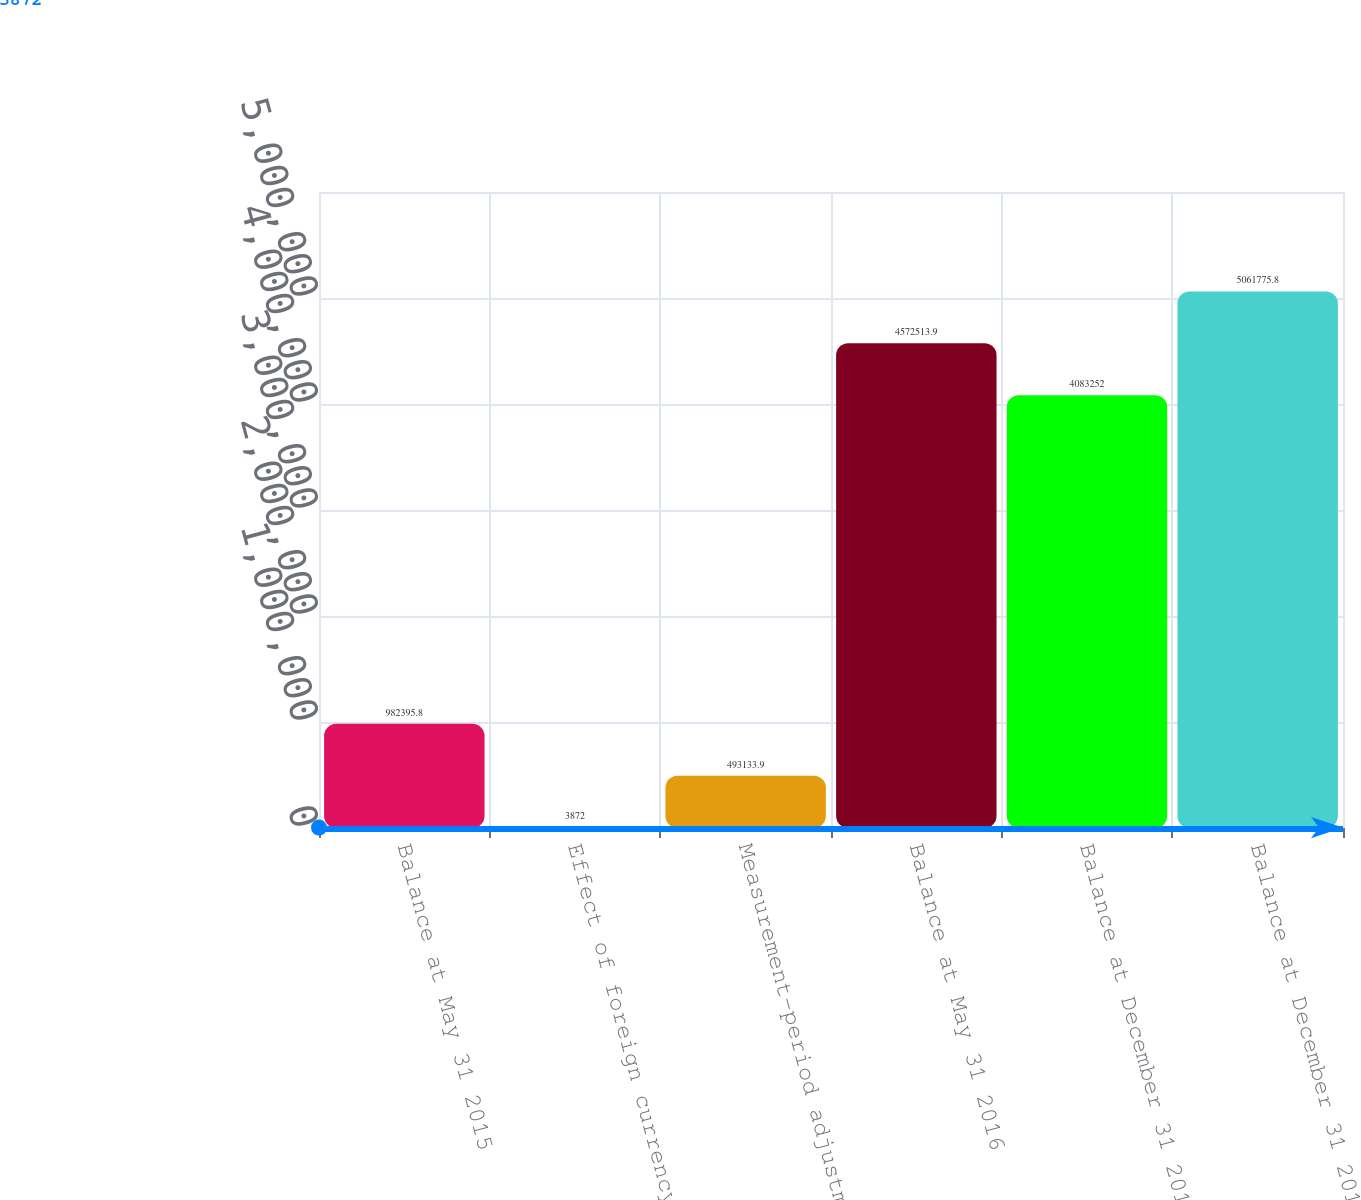Convert chart. <chart><loc_0><loc_0><loc_500><loc_500><bar_chart><fcel>Balance at May 31 2015<fcel>Effect of foreign currency<fcel>Measurement-period adjustments<fcel>Balance at May 31 2016<fcel>Balance at December 31 2016<fcel>Balance at December 31 2017<nl><fcel>982396<fcel>3872<fcel>493134<fcel>4.57251e+06<fcel>4.08325e+06<fcel>5.06178e+06<nl></chart> 